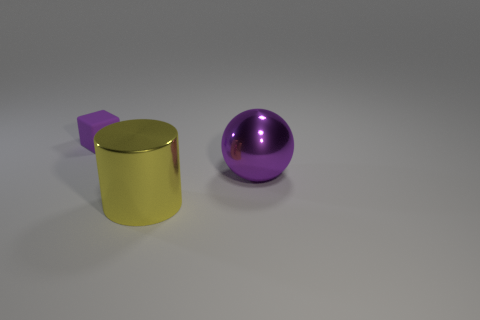Is the material of the thing that is behind the sphere the same as the thing in front of the large purple ball?
Make the answer very short. No. What shape is the purple thing left of the yellow cylinder?
Your response must be concise. Cube. What number of things are either blue metallic objects or objects left of the big shiny cylinder?
Make the answer very short. 1. Is the material of the big purple ball the same as the cylinder?
Provide a succinct answer. Yes. Are there an equal number of big purple spheres in front of the large yellow cylinder and large shiny things that are behind the large purple metal sphere?
Provide a succinct answer. Yes. There is a yellow thing; how many small rubber blocks are to the left of it?
Make the answer very short. 1. How many objects are either metal spheres or large metallic objects?
Your response must be concise. 2. What number of yellow metallic cylinders have the same size as the purple ball?
Provide a succinct answer. 1. The large metal thing that is on the left side of the big metallic object behind the large metallic cylinder is what shape?
Make the answer very short. Cylinder. Is the number of tiny matte things less than the number of large purple metal cubes?
Ensure brevity in your answer.  No. 